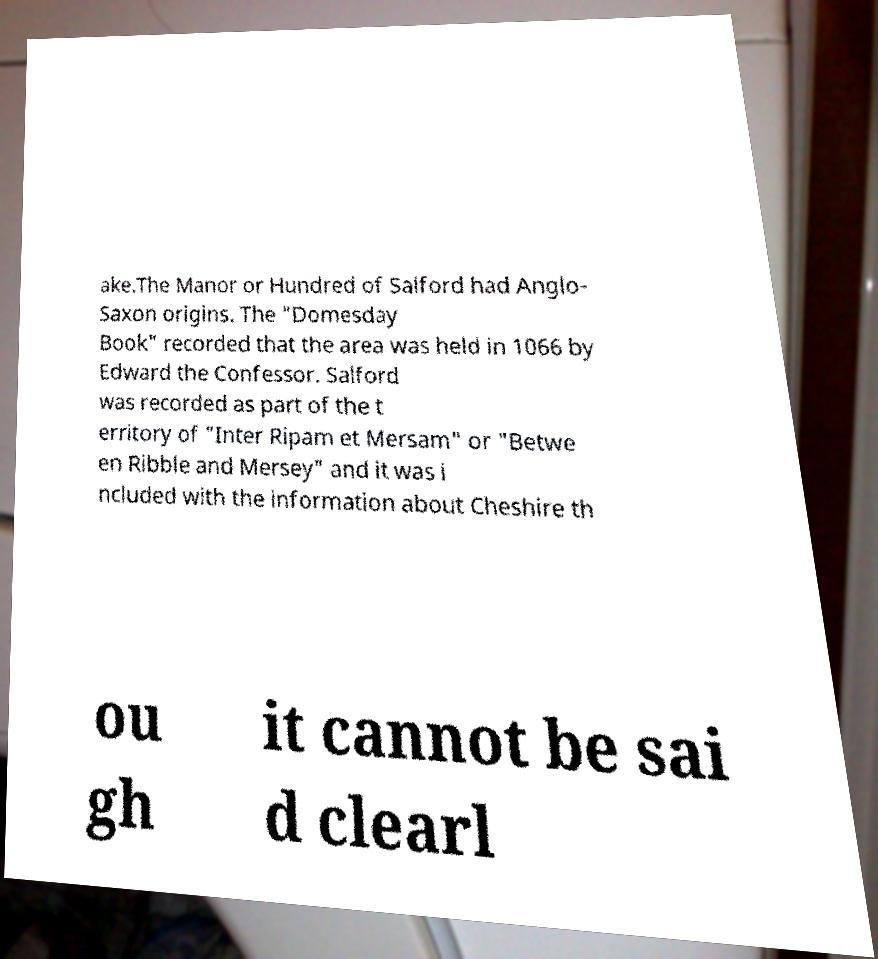Can you read and provide the text displayed in the image?This photo seems to have some interesting text. Can you extract and type it out for me? ake.The Manor or Hundred of Salford had Anglo- Saxon origins. The "Domesday Book" recorded that the area was held in 1066 by Edward the Confessor. Salford was recorded as part of the t erritory of "Inter Ripam et Mersam" or "Betwe en Ribble and Mersey" and it was i ncluded with the information about Cheshire th ou gh it cannot be sai d clearl 